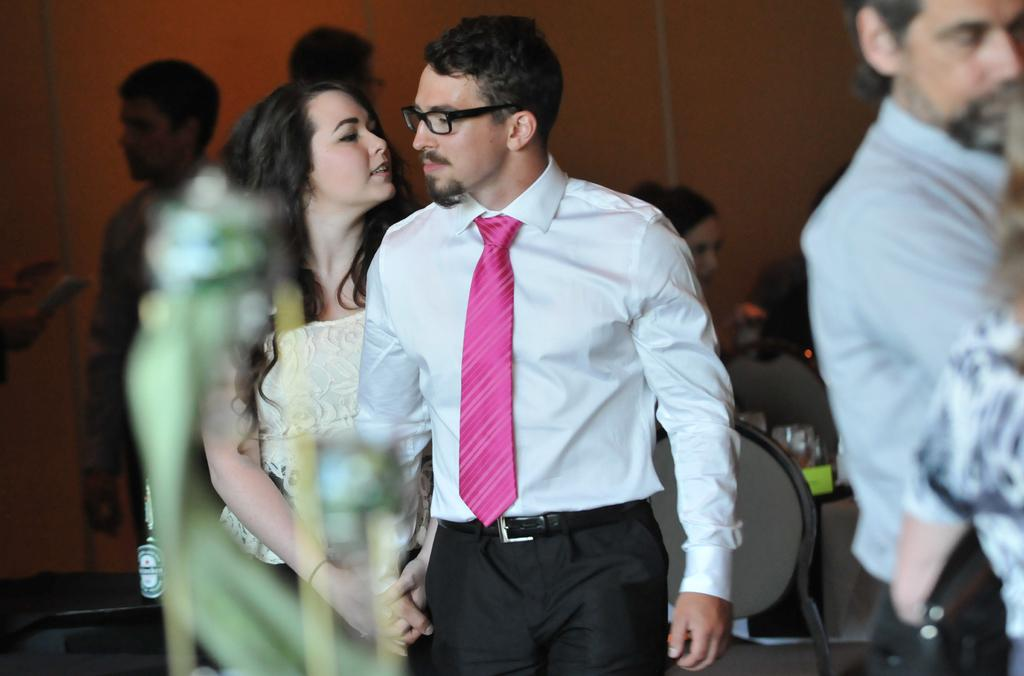Who or what is present in the image? There are people in the image. What objects are behind the people? There are chairs behind the people. What piece of furniture is in the image? There is a table in the image. What can be found on the table? There are glasses on the table. What can be seen in the background of the image? There is a wall in the background of the image. Can you tell me the name of the grandfather in the image? There is no mention of a grandfather in the image or the provided facts. 